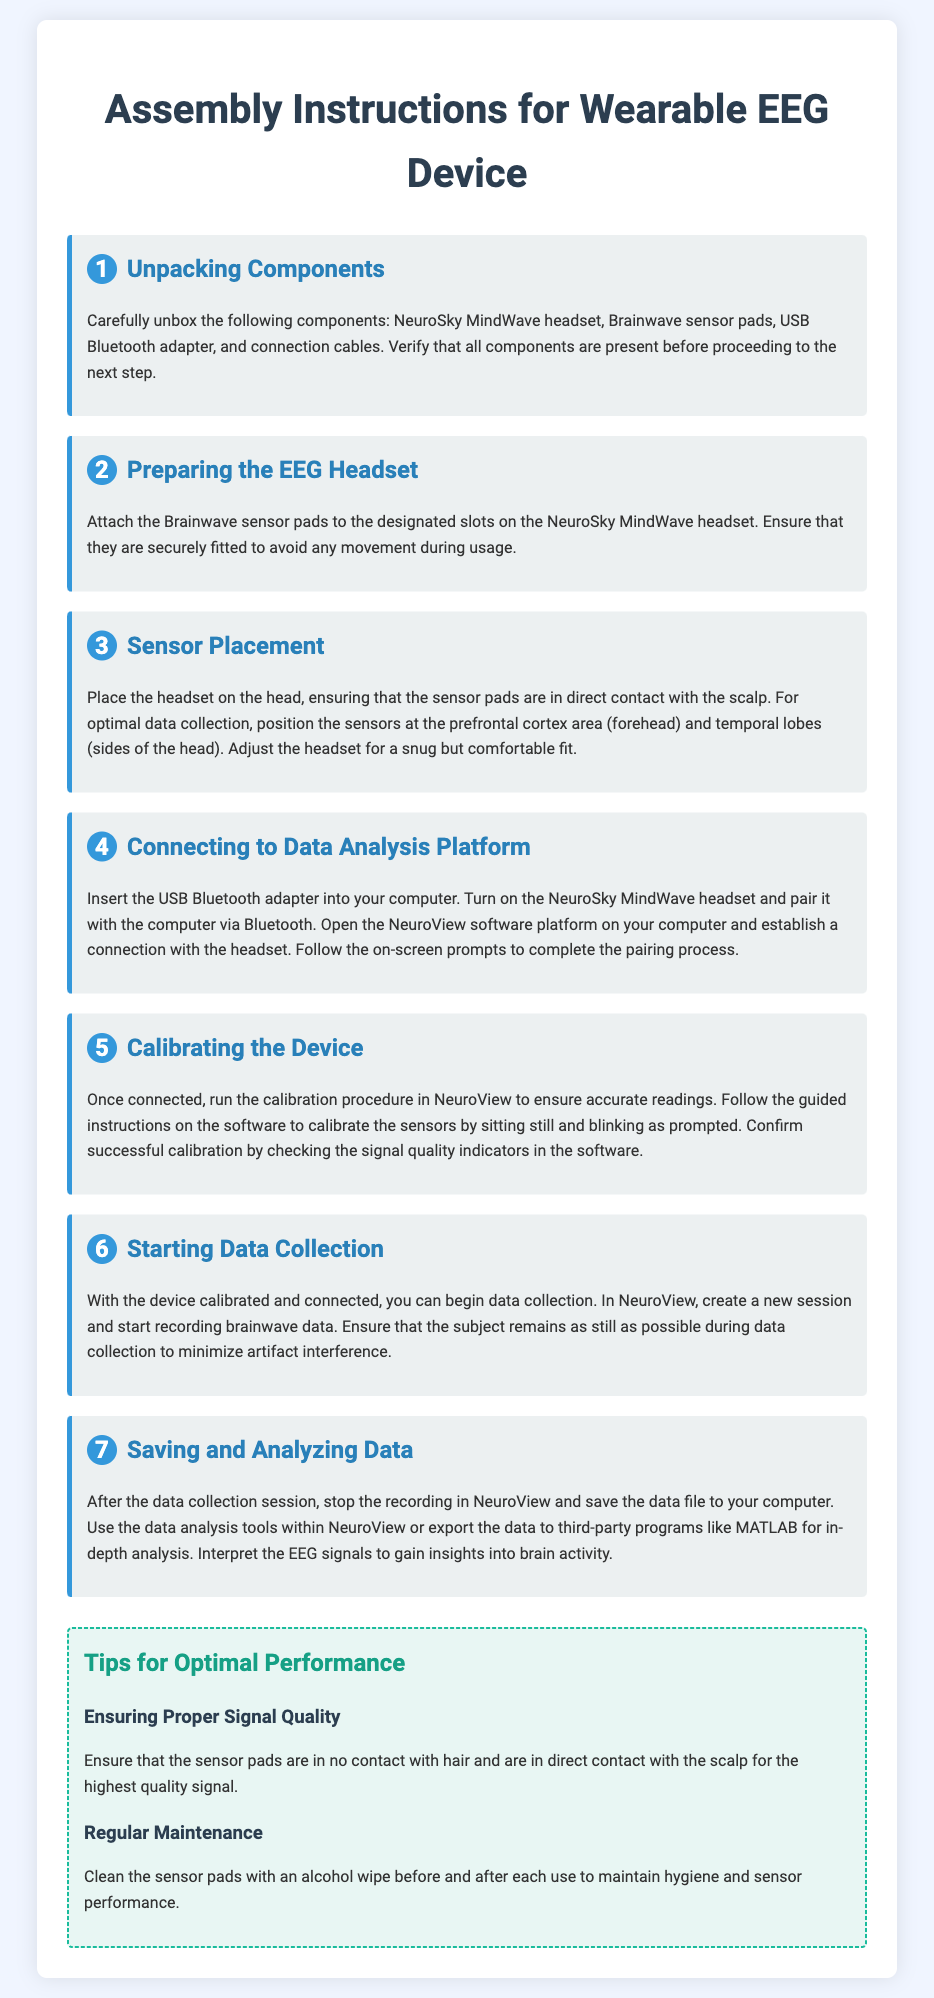What components are included in the assembly? The document lists the components as NeuroSky MindWave headset, Brainwave sensor pads, USB Bluetooth adapter, and connection cables.
Answer: NeuroSky MindWave headset, Brainwave sensor pads, USB Bluetooth adapter, connection cables What is the first step in assembling the device? The first step involves carefully unboxing the listed components and verifying their presence.
Answer: Unpacking Components Where should the sensor pads be placed for optimal data collection? The document specifies placing the sensor pads at the prefrontal cortex area (forehead) and temporal lobes (sides of the head).
Answer: Prefrontal cortex area, temporal lobes What do you need to do to connect the headset to the computer? The connection process involves inserting a USB Bluetooth adapter, turning on the headset, and pairing it with the computer via Bluetooth.
Answer: Pair it via Bluetooth How should the device be calibrated? The calibration process requires running the calibration procedure in NeuroView and following guided instructions to ensure accurate readings.
Answer: Follow guided instructions What should you do after the data collection session? After collecting data, you need to stop the recording in NeuroView and save the data file to your computer.
Answer: Stop recording and save data file What is one tip for ensuring proper signal quality? The document suggests ensuring that sensor pads are in direct contact with the scalp and not touching hair.
Answer: Direct contact with scalp What software platform is mentioned for the data analysis? The document mentions the NeuroView software platform for connecting to and analyzing EEG data.
Answer: NeuroView How many steps are outlined in the assembly instructions? The document outlines a total of seven steps for assembly.
Answer: Seven steps 